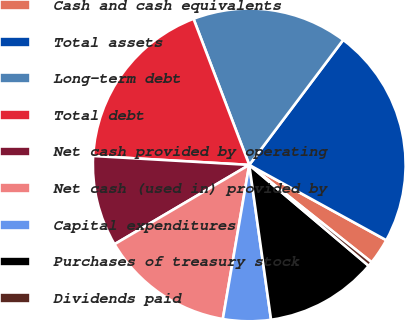Convert chart. <chart><loc_0><loc_0><loc_500><loc_500><pie_chart><fcel>Cash and cash equivalents<fcel>Total assets<fcel>Long-term debt<fcel>Total debt<fcel>Net cash provided by operating<fcel>Net cash (used in) provided by<fcel>Capital expenditures<fcel>Purchases of treasury stock<fcel>Dividends paid<nl><fcel>2.7%<fcel>22.74%<fcel>16.06%<fcel>18.29%<fcel>9.38%<fcel>13.83%<fcel>4.93%<fcel>11.61%<fcel>0.47%<nl></chart> 